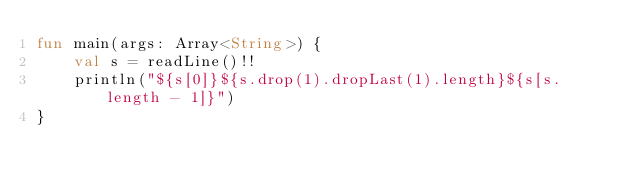Convert code to text. <code><loc_0><loc_0><loc_500><loc_500><_Kotlin_>fun main(args: Array<String>) {
    val s = readLine()!!
    println("${s[0]}${s.drop(1).dropLast(1).length}${s[s.length - 1]}")
}</code> 